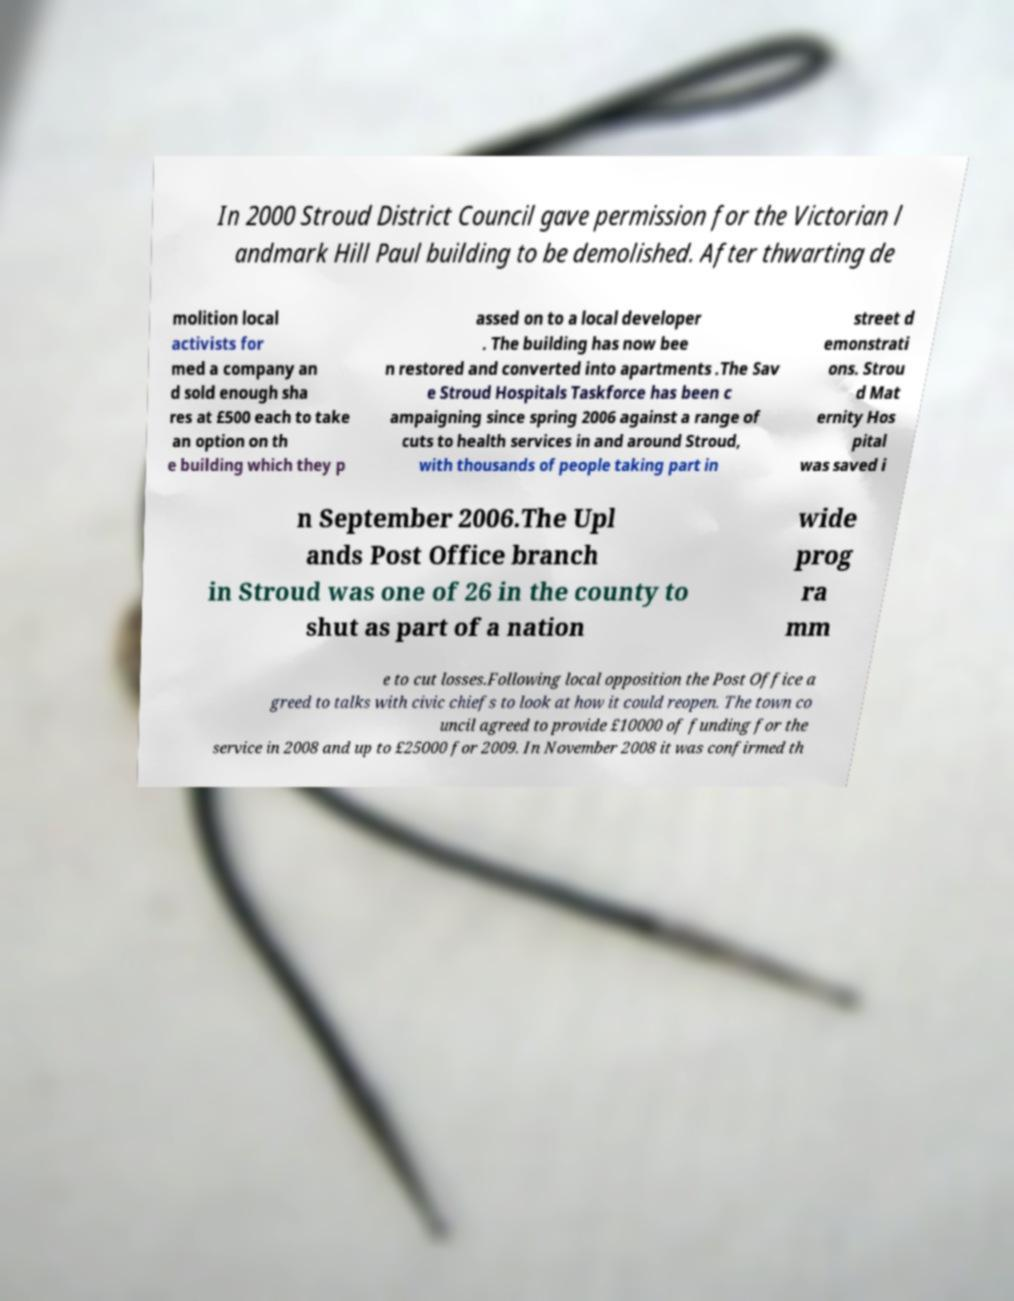Could you extract and type out the text from this image? In 2000 Stroud District Council gave permission for the Victorian l andmark Hill Paul building to be demolished. After thwarting de molition local activists for med a company an d sold enough sha res at £500 each to take an option on th e building which they p assed on to a local developer . The building has now bee n restored and converted into apartments .The Sav e Stroud Hospitals Taskforce has been c ampaigning since spring 2006 against a range of cuts to health services in and around Stroud, with thousands of people taking part in street d emonstrati ons. Strou d Mat ernity Hos pital was saved i n September 2006.The Upl ands Post Office branch in Stroud was one of 26 in the county to shut as part of a nation wide prog ra mm e to cut losses.Following local opposition the Post Office a greed to talks with civic chiefs to look at how it could reopen. The town co uncil agreed to provide £10000 of funding for the service in 2008 and up to £25000 for 2009. In November 2008 it was confirmed th 